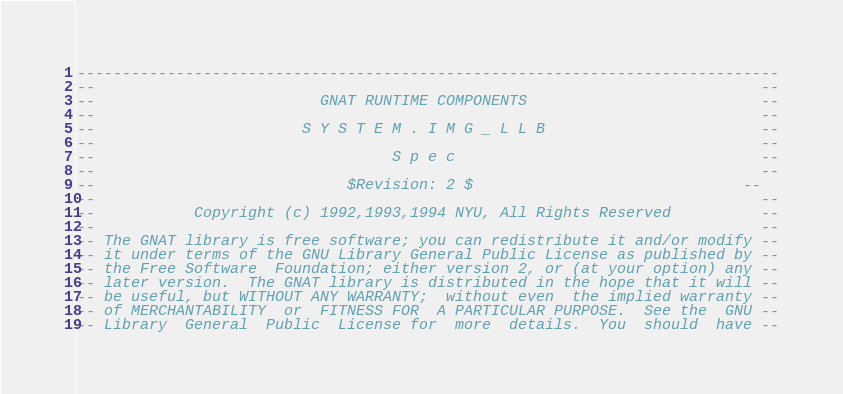Convert code to text. <code><loc_0><loc_0><loc_500><loc_500><_Ada_>------------------------------------------------------------------------------
--                                                                          --
--                         GNAT RUNTIME COMPONENTS                          --
--                                                                          --
--                       S Y S T E M . I M G _ L L B                        --
--                                                                          --
--                                 S p e c                                  --
--                                                                          --
--                            $Revision: 2 $                              --
--                                                                          --
--           Copyright (c) 1992,1993,1994 NYU, All Rights Reserved          --
--                                                                          --
-- The GNAT library is free software; you can redistribute it and/or modify --
-- it under terms of the GNU Library General Public License as published by --
-- the Free Software  Foundation; either version 2, or (at your option) any --
-- later version.  The GNAT library is distributed in the hope that it will --
-- be useful, but WITHOUT ANY WARRANTY;  without even  the implied warranty --
-- of MERCHANTABILITY  or  FITNESS FOR  A PARTICULAR PURPOSE.  See the  GNU --
-- Library  General  Public  License for  more  details.  You  should  have --</code> 